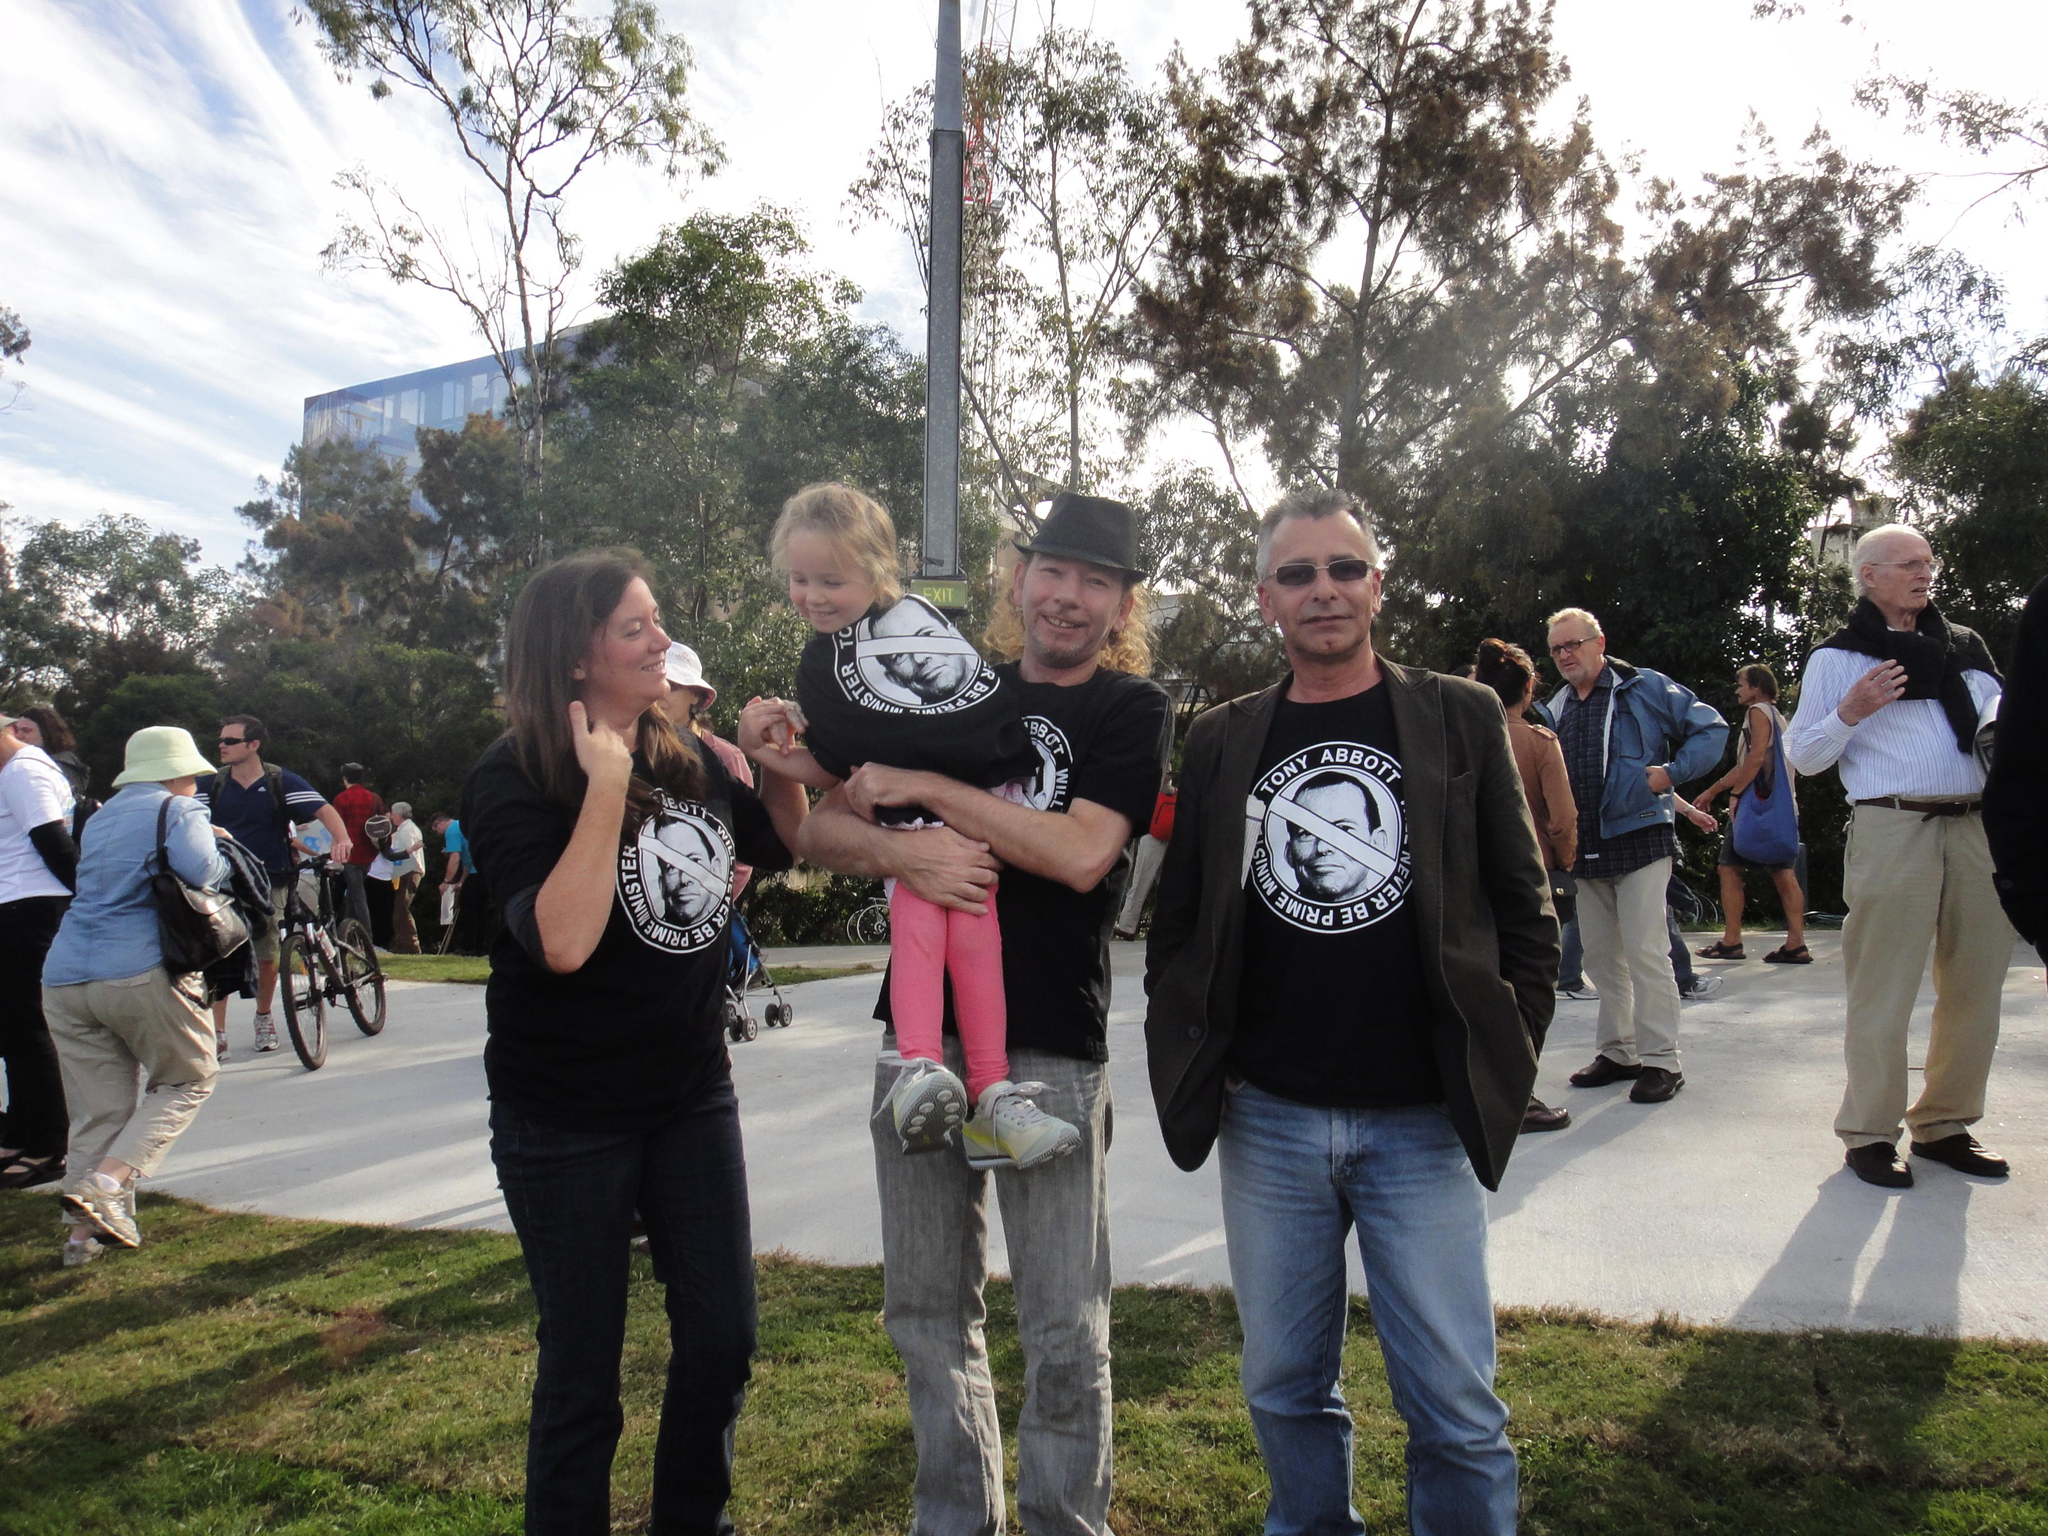What is happening with the people in the image? The people are standing on the land in the image. Can you describe the gender of the people in the image? There are men and women in the image. What can be seen in the background of the image? There are trees and the sky visible in the background of the image. What type of pot can be seen in the image? There is no pot present in the image. How many pieces of quartz are visible in the image? There is no quartz present in the image. 